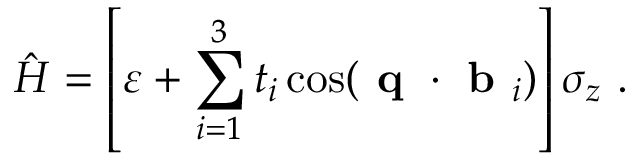Convert formula to latex. <formula><loc_0><loc_0><loc_500><loc_500>\hat { H } = \left [ \varepsilon + \sum _ { i = 1 } ^ { 3 } t _ { i } \cos ( q \cdot b _ { i } ) \right ] \sigma _ { z } .</formula> 